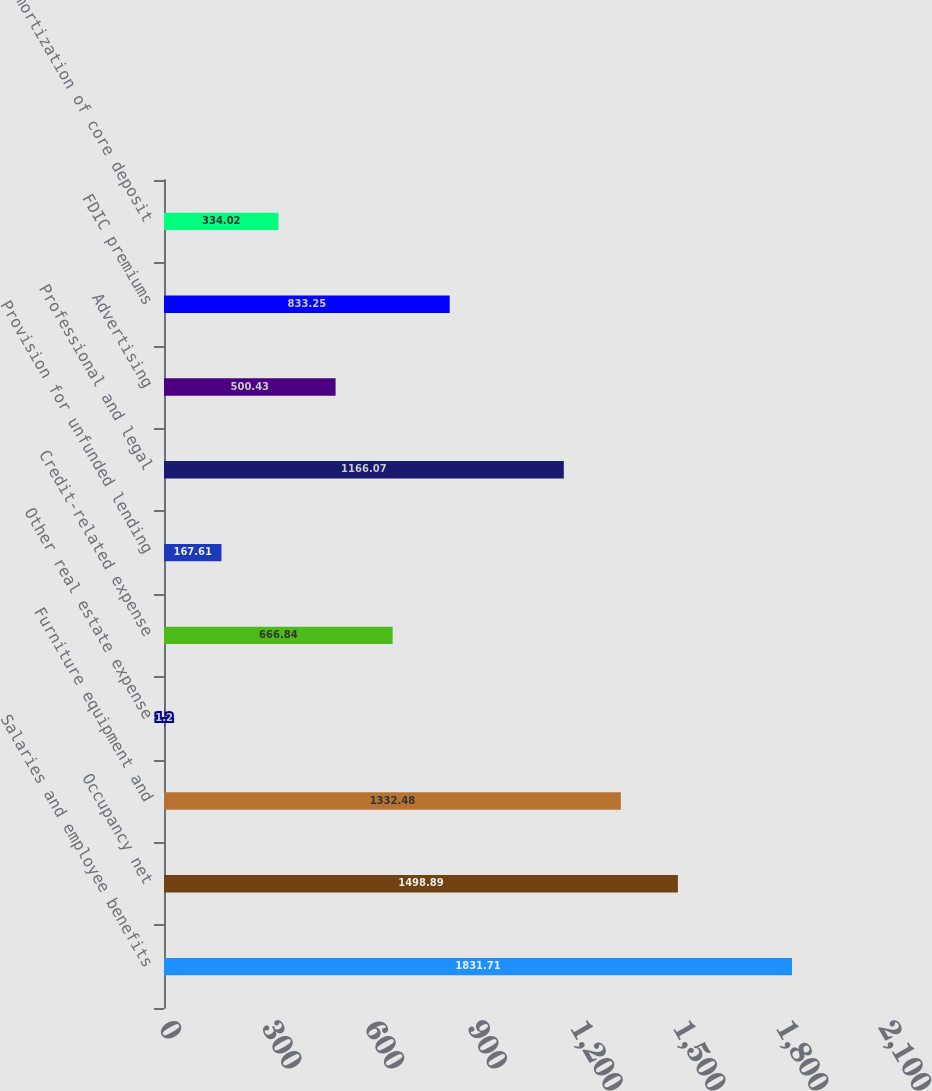<chart> <loc_0><loc_0><loc_500><loc_500><bar_chart><fcel>Salaries and employee benefits<fcel>Occupancy net<fcel>Furniture equipment and<fcel>Other real estate expense<fcel>Credit-related expense<fcel>Provision for unfunded lending<fcel>Professional and legal<fcel>Advertising<fcel>FDIC premiums<fcel>Amortization of core deposit<nl><fcel>1831.71<fcel>1498.89<fcel>1332.48<fcel>1.2<fcel>666.84<fcel>167.61<fcel>1166.07<fcel>500.43<fcel>833.25<fcel>334.02<nl></chart> 